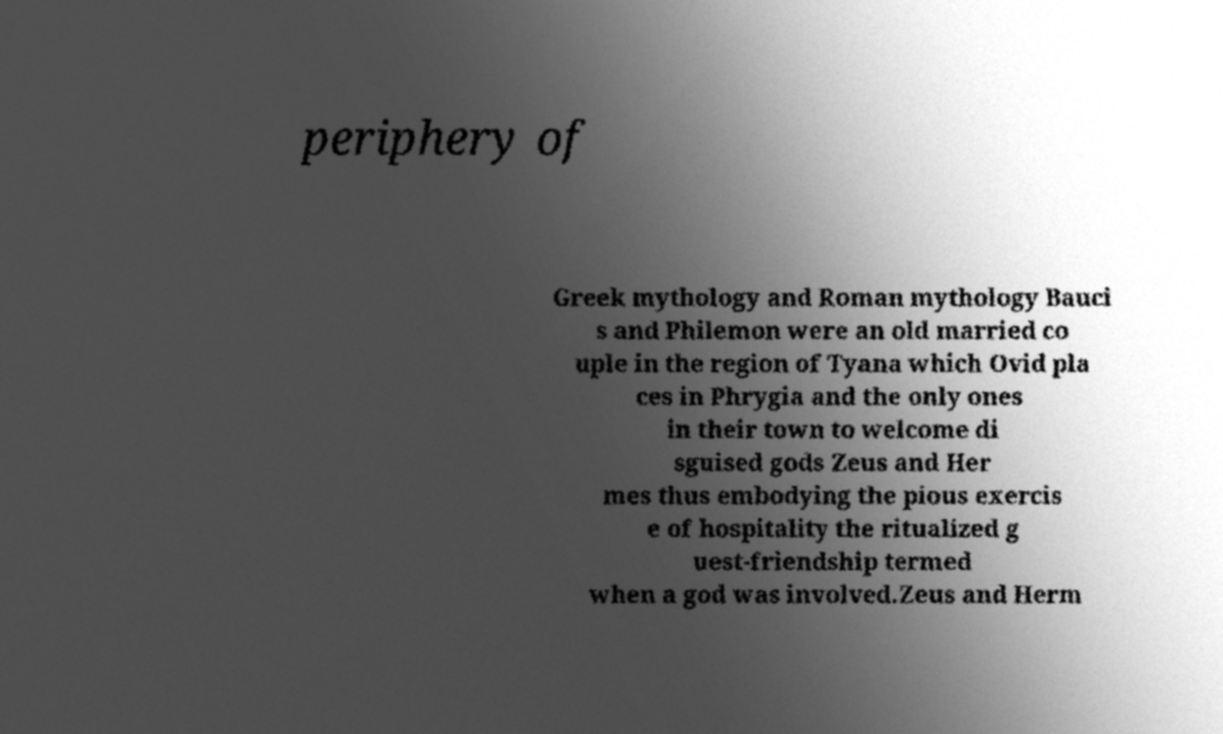Please identify and transcribe the text found in this image. periphery of Greek mythology and Roman mythology Bauci s and Philemon were an old married co uple in the region of Tyana which Ovid pla ces in Phrygia and the only ones in their town to welcome di sguised gods Zeus and Her mes thus embodying the pious exercis e of hospitality the ritualized g uest-friendship termed when a god was involved.Zeus and Herm 